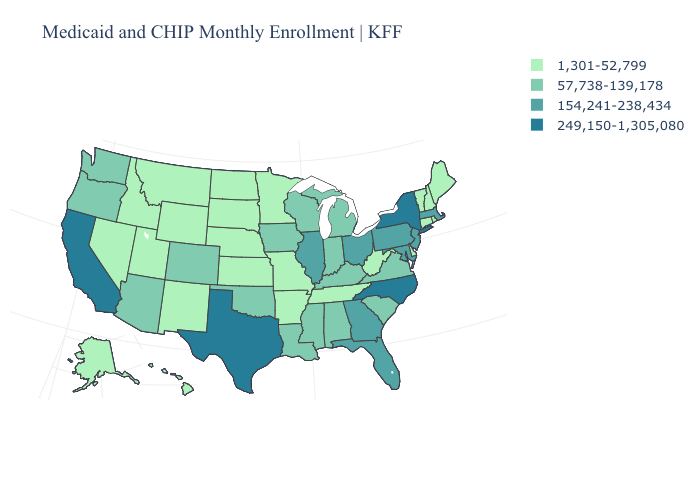Does the first symbol in the legend represent the smallest category?
Be succinct. Yes. What is the value of Idaho?
Keep it brief. 1,301-52,799. Does Kentucky have the lowest value in the USA?
Concise answer only. No. Does Massachusetts have the same value as Georgia?
Short answer required. Yes. What is the value of New Jersey?
Quick response, please. 154,241-238,434. What is the value of Connecticut?
Short answer required. 1,301-52,799. Name the states that have a value in the range 249,150-1,305,080?
Write a very short answer. California, New York, North Carolina, Texas. Does South Carolina have the same value as Tennessee?
Write a very short answer. No. What is the value of Hawaii?
Keep it brief. 1,301-52,799. Name the states that have a value in the range 154,241-238,434?
Keep it brief. Florida, Georgia, Illinois, Maryland, Massachusetts, New Jersey, Ohio, Pennsylvania. What is the value of Delaware?
Short answer required. 1,301-52,799. Does New York have the lowest value in the USA?
Be succinct. No. What is the value of Alaska?
Write a very short answer. 1,301-52,799. Among the states that border Ohio , does Kentucky have the lowest value?
Be succinct. No. 